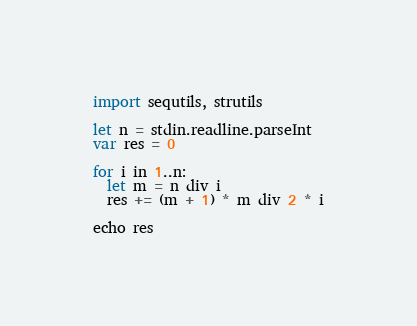<code> <loc_0><loc_0><loc_500><loc_500><_Nim_>import sequtils, strutils

let n = stdin.readline.parseInt
var res = 0

for i in 1..n:
  let m = n div i 
  res += (m + 1) * m div 2 * i

echo res
</code> 